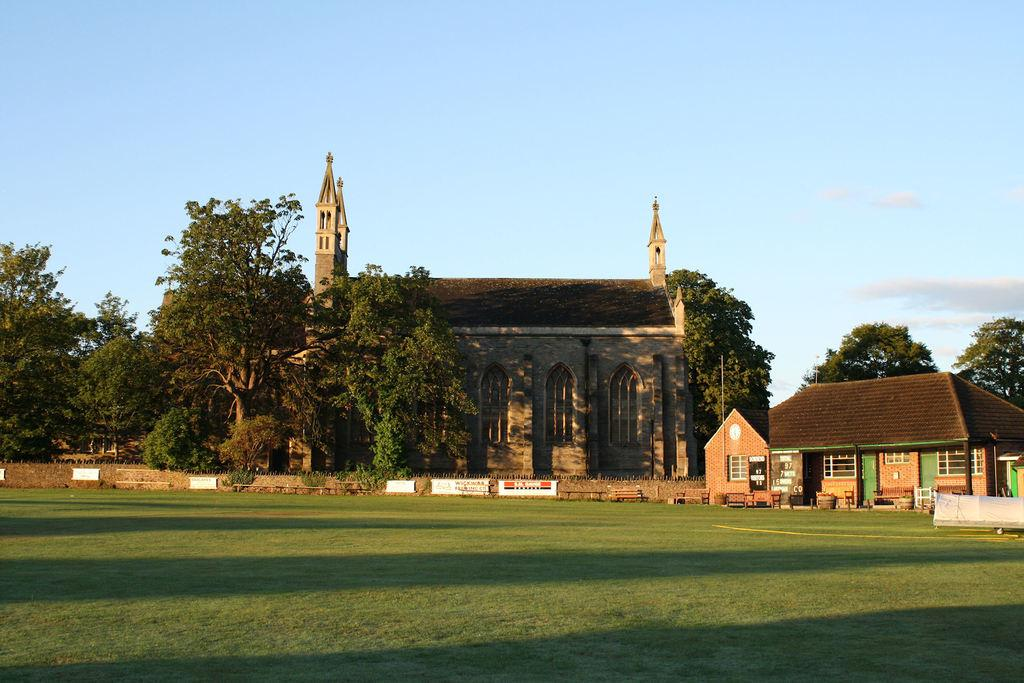What type of outdoor space is depicted in the image? There is a garden in the image. What natural elements can be seen in the garden? There are trees in the garden. Are there any structures within the garden? Yes, there is a house in the garden. What can be seen in the background of the image? The sky is visible in the background of the image. What type of yarn is being used to create the letters in the garden? There is no yarn or letters present in the garden in the image. 